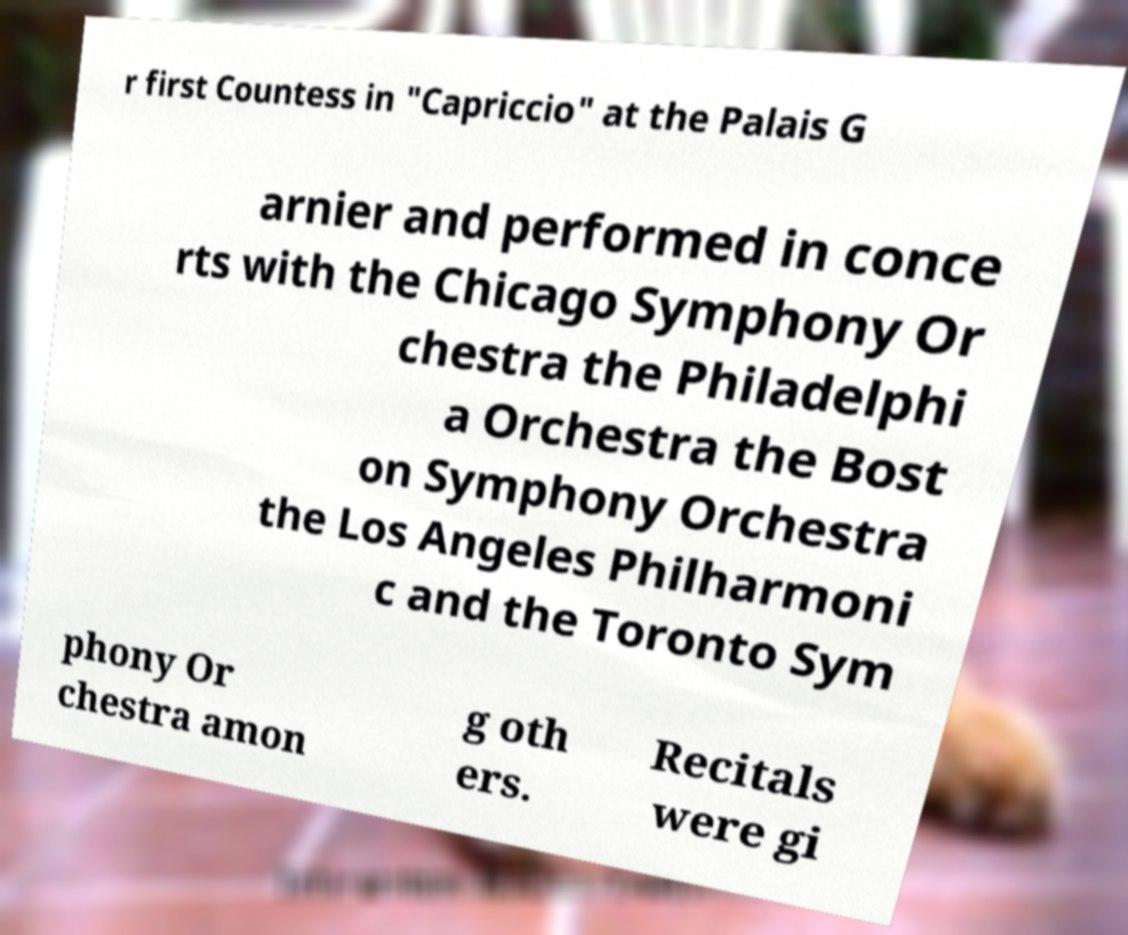Can you read and provide the text displayed in the image?This photo seems to have some interesting text. Can you extract and type it out for me? r first Countess in "Capriccio" at the Palais G arnier and performed in conce rts with the Chicago Symphony Or chestra the Philadelphi a Orchestra the Bost on Symphony Orchestra the Los Angeles Philharmoni c and the Toronto Sym phony Or chestra amon g oth ers. Recitals were gi 